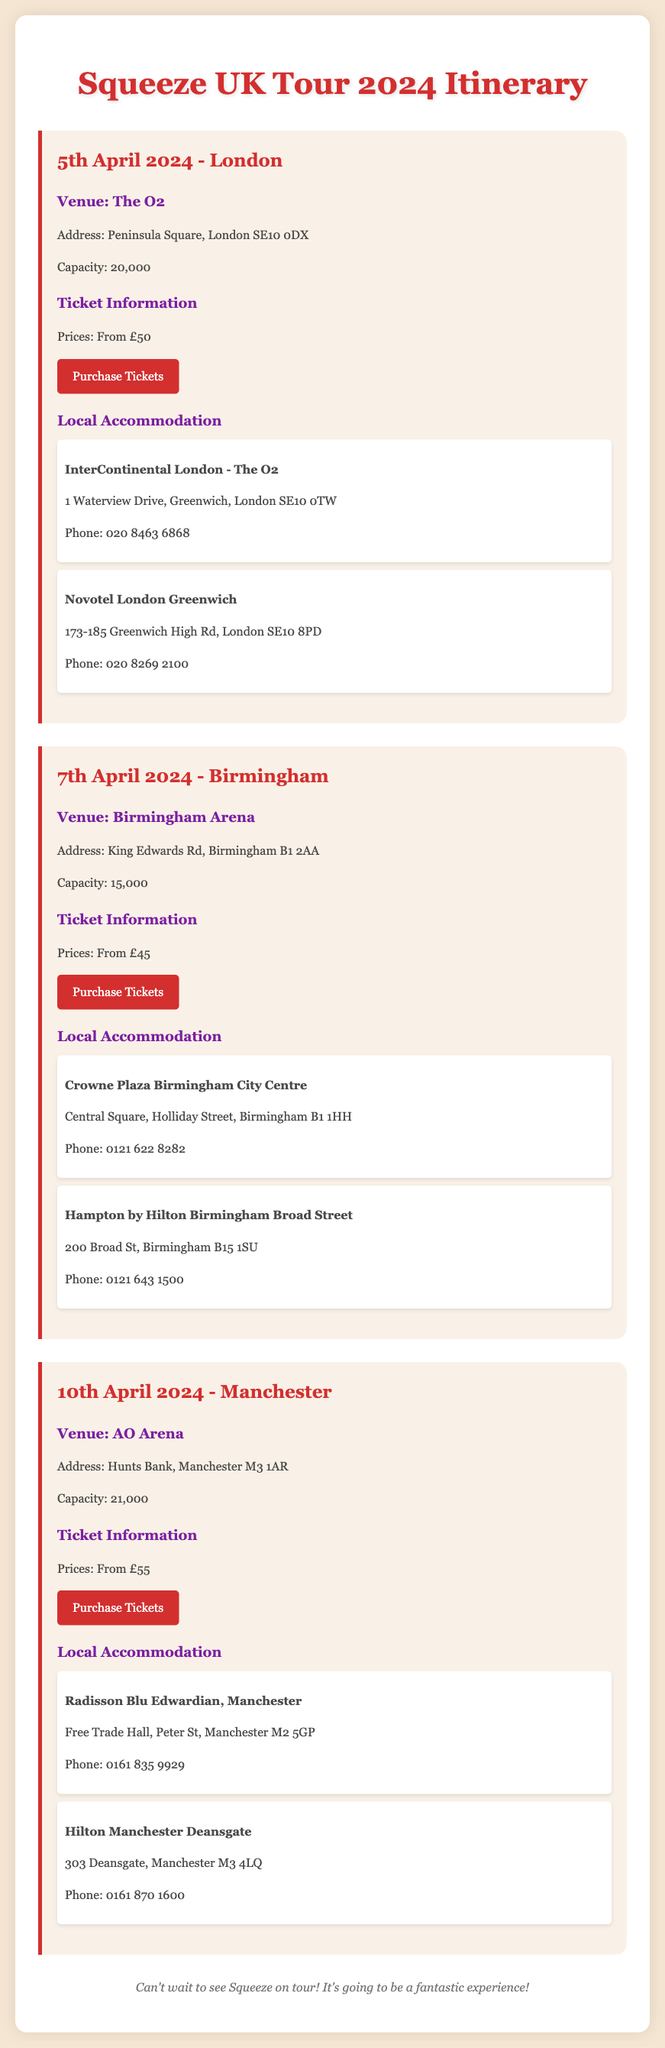What is the date of the London concert? The date of the London concert is clearly stated in the document.
Answer: 5th April 2024 What is the capacity of Birmingham Arena? The document specifies the capacity for each venue, including Birmingham Arena.
Answer: 15,000 Where is the venue for the Manchester concert? The venue for the Manchester concert is listed in the itinerary.
Answer: AO Arena What is the price of tickets for the London concert? The ticket prices for the London concert are provided in the document.
Answer: From £50 Which hotel is suggested for accommodation in Birmingham? The itinerary includes suggestions for local accommodation in Birmingham.
Answer: Crowne Plaza Birmingham City Centre How many concerts are listed in the document? The document outlines specific concert dates and locations.
Answer: 3 Which city will Squeeze perform in on April 10th? The specific date of the concert and the corresponding city are mentioned.
Answer: Manchester What is the phone number for the InterContinental London - The O2? The accommodation details include contact information, including phone numbers.
Answer: 020 8463 6868 What is the address of The O2 venue? The venue details include the complete address of The O2.
Answer: Peninsula Square, London SE10 0DX 